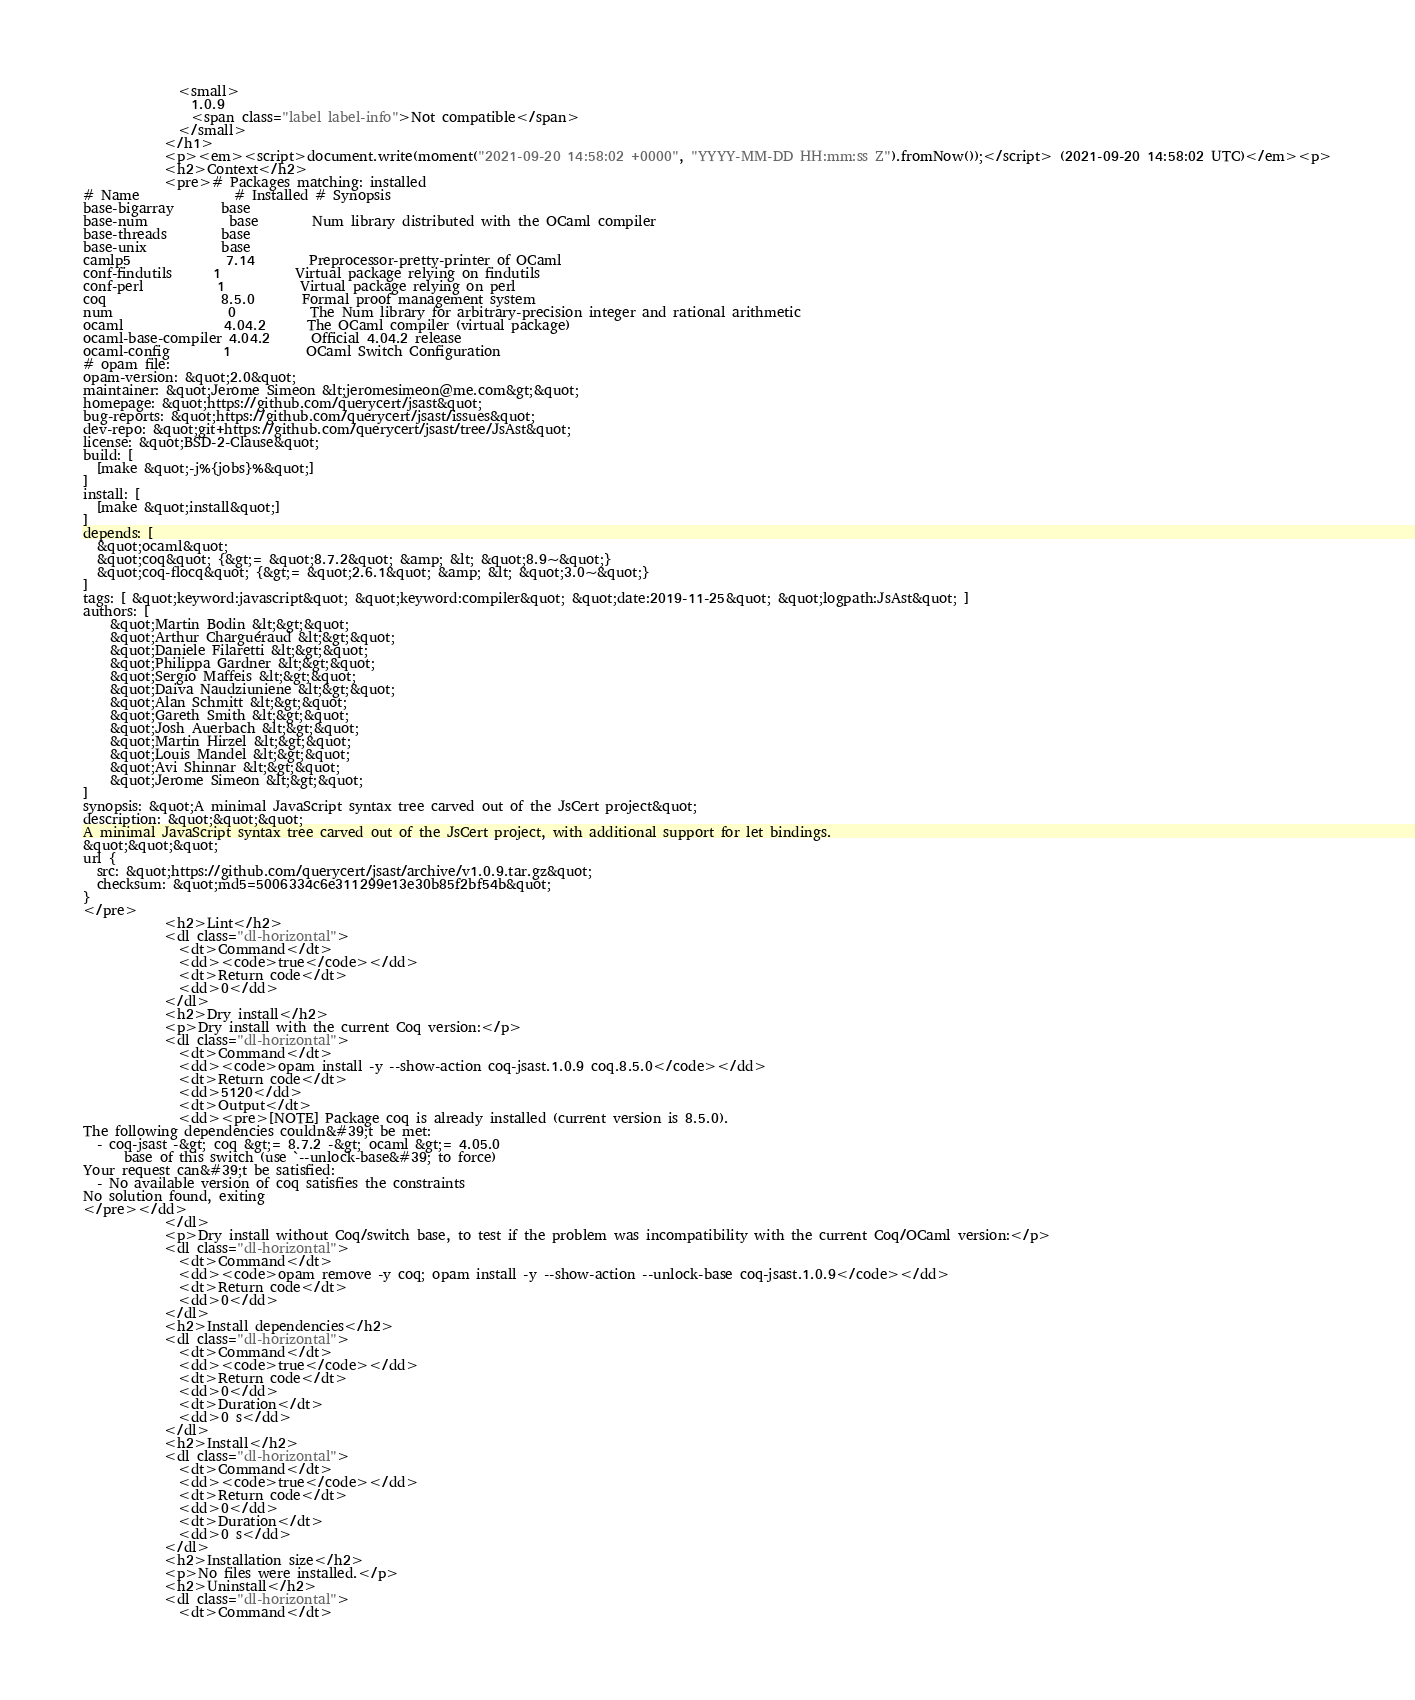Convert code to text. <code><loc_0><loc_0><loc_500><loc_500><_HTML_>              <small>
                1.0.9
                <span class="label label-info">Not compatible</span>
              </small>
            </h1>
            <p><em><script>document.write(moment("2021-09-20 14:58:02 +0000", "YYYY-MM-DD HH:mm:ss Z").fromNow());</script> (2021-09-20 14:58:02 UTC)</em><p>
            <h2>Context</h2>
            <pre># Packages matching: installed
# Name              # Installed # Synopsis
base-bigarray       base
base-num            base        Num library distributed with the OCaml compiler
base-threads        base
base-unix           base
camlp5              7.14        Preprocessor-pretty-printer of OCaml
conf-findutils      1           Virtual package relying on findutils
conf-perl           1           Virtual package relying on perl
coq                 8.5.0       Formal proof management system
num                 0           The Num library for arbitrary-precision integer and rational arithmetic
ocaml               4.04.2      The OCaml compiler (virtual package)
ocaml-base-compiler 4.04.2      Official 4.04.2 release
ocaml-config        1           OCaml Switch Configuration
# opam file:
opam-version: &quot;2.0&quot;
maintainer: &quot;Jerome Simeon &lt;jeromesimeon@me.com&gt;&quot;
homepage: &quot;https://github.com/querycert/jsast&quot;
bug-reports: &quot;https://github.com/querycert/jsast/issues&quot;
dev-repo: &quot;git+https://github.com/querycert/jsast/tree/JsAst&quot;
license: &quot;BSD-2-Clause&quot;
build: [
  [make &quot;-j%{jobs}%&quot;]
]
install: [
  [make &quot;install&quot;]
]
depends: [
  &quot;ocaml&quot;
  &quot;coq&quot; {&gt;= &quot;8.7.2&quot; &amp; &lt; &quot;8.9~&quot;}
  &quot;coq-flocq&quot; {&gt;= &quot;2.6.1&quot; &amp; &lt; &quot;3.0~&quot;}
]
tags: [ &quot;keyword:javascript&quot; &quot;keyword:compiler&quot; &quot;date:2019-11-25&quot; &quot;logpath:JsAst&quot; ]
authors: [
    &quot;Martin Bodin &lt;&gt;&quot;
    &quot;Arthur Charguéraud &lt;&gt;&quot;
    &quot;Daniele Filaretti &lt;&gt;&quot;
    &quot;Philippa Gardner &lt;&gt;&quot;
    &quot;Sergio Maffeis &lt;&gt;&quot;
    &quot;Daiva Naudziuniene &lt;&gt;&quot;
    &quot;Alan Schmitt &lt;&gt;&quot;
    &quot;Gareth Smith &lt;&gt;&quot;
    &quot;Josh Auerbach &lt;&gt;&quot;
    &quot;Martin Hirzel &lt;&gt;&quot;
    &quot;Louis Mandel &lt;&gt;&quot;
    &quot;Avi Shinnar &lt;&gt;&quot;
    &quot;Jerome Simeon &lt;&gt;&quot;
]
synopsis: &quot;A minimal JavaScript syntax tree carved out of the JsCert project&quot;
description: &quot;&quot;&quot;
A minimal JavaScript syntax tree carved out of the JsCert project, with additional support for let bindings.
&quot;&quot;&quot;
url {
  src: &quot;https://github.com/querycert/jsast/archive/v1.0.9.tar.gz&quot;
  checksum: &quot;md5=5006334c6e311299e13e30b85f2bf54b&quot;
}
</pre>
            <h2>Lint</h2>
            <dl class="dl-horizontal">
              <dt>Command</dt>
              <dd><code>true</code></dd>
              <dt>Return code</dt>
              <dd>0</dd>
            </dl>
            <h2>Dry install</h2>
            <p>Dry install with the current Coq version:</p>
            <dl class="dl-horizontal">
              <dt>Command</dt>
              <dd><code>opam install -y --show-action coq-jsast.1.0.9 coq.8.5.0</code></dd>
              <dt>Return code</dt>
              <dd>5120</dd>
              <dt>Output</dt>
              <dd><pre>[NOTE] Package coq is already installed (current version is 8.5.0).
The following dependencies couldn&#39;t be met:
  - coq-jsast -&gt; coq &gt;= 8.7.2 -&gt; ocaml &gt;= 4.05.0
      base of this switch (use `--unlock-base&#39; to force)
Your request can&#39;t be satisfied:
  - No available version of coq satisfies the constraints
No solution found, exiting
</pre></dd>
            </dl>
            <p>Dry install without Coq/switch base, to test if the problem was incompatibility with the current Coq/OCaml version:</p>
            <dl class="dl-horizontal">
              <dt>Command</dt>
              <dd><code>opam remove -y coq; opam install -y --show-action --unlock-base coq-jsast.1.0.9</code></dd>
              <dt>Return code</dt>
              <dd>0</dd>
            </dl>
            <h2>Install dependencies</h2>
            <dl class="dl-horizontal">
              <dt>Command</dt>
              <dd><code>true</code></dd>
              <dt>Return code</dt>
              <dd>0</dd>
              <dt>Duration</dt>
              <dd>0 s</dd>
            </dl>
            <h2>Install</h2>
            <dl class="dl-horizontal">
              <dt>Command</dt>
              <dd><code>true</code></dd>
              <dt>Return code</dt>
              <dd>0</dd>
              <dt>Duration</dt>
              <dd>0 s</dd>
            </dl>
            <h2>Installation size</h2>
            <p>No files were installed.</p>
            <h2>Uninstall</h2>
            <dl class="dl-horizontal">
              <dt>Command</dt></code> 